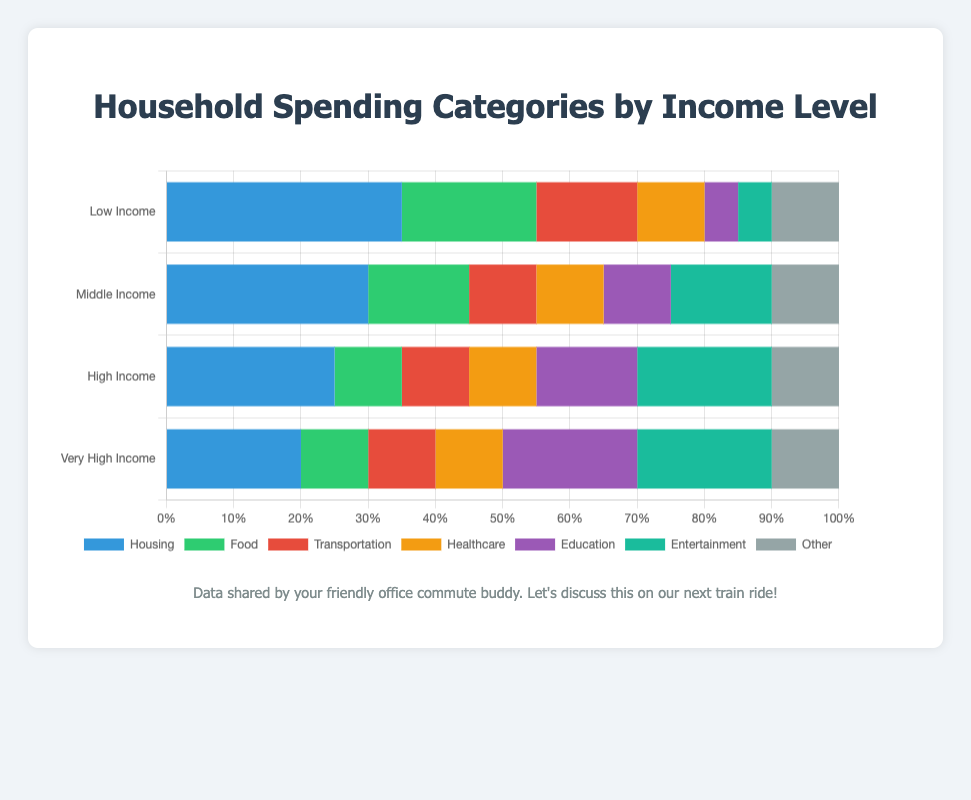What income level spends the highest percentage on education? By looking at the stacked bar chart, the segment representing education is largest for the Very High Income group. In this group, education spending is at 20%.
Answer: Very High Income How much more does the Low Income group spend on housing compared to the Very High Income group? The Low Income group spends 35% on housing whereas the Very High Income group spends 20%. The difference is 35% - 20% = 15%.
Answer: 15% Which income level spends the least on food? Observing the stacked bar chart, the High Income and Very High Income groups both spend 10% on food, which is the smallest percentage among the groups.
Answer: High Income and Very High Income Summing up the spending percentages on healthcare and entertainment for the Middle Income group, what do you get? For the Middle Income group, healthcare spending is 10% and entertainment spending is 15%. Adding them together gives 10% + 15% = 25%.
Answer: 25% How does the percentage of spending on transportation compare between the Low Income and Middle Income groups? Both the Low Income and Middle Income groups spend the same percentage on transportation, which is 10%.
Answer: Equal Which spending category is the most consistent across all income levels? By examining the stacked bar chart, we see that the 'Other' category has a consistent percentage of 10% across all income levels.
Answer: Other If you add up the percentages for food, housing, and healthcare for the High Income group, what is the total? For the High Income group, the percentages are 10% for food, 25% for housing, and 10% for healthcare. Adding these gives 10% + 25% + 10% = 45%.
Answer: 45% Compare the percentage of spending on entertainment between the Low Income and Very High Income groups. Which group spends more and by how much? The Low Income group spends 5% on entertainment while the Very High Income group spends 20%. The Very High Income group spends 15% more, calculated as 20% - 5% = 15%.
Answer: Very High Income by 15% Which income group allocates exactly 10% of their budget to four different categories? The Middle Income group spends exactly 10% of their budget on transportation, healthcare, education, and other categories.
Answer: Middle Income Adding up the percentages for food and transportation, which income level has the highest total? By summing food and transportation for each group: Low Income (20% + 15% = 35%), Middle Income (15% + 10% = 25%), High Income (10% + 10% = 20%), Very High Income (10% + 10% = 20%). The Low Income group has the highest total at 35%.
Answer: Low Income 